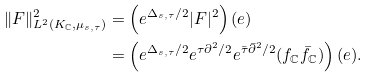Convert formula to latex. <formula><loc_0><loc_0><loc_500><loc_500>\| F \| _ { L ^ { 2 } ( K _ { \mathbb { C } } , \mu _ { s , \tau } ) } ^ { 2 } & = \left ( e ^ { \Delta _ { s , \tau } / 2 } | F | ^ { 2 } \right ) ( e ) \\ & = \left ( e ^ { \Delta _ { s , \tau } / 2 } e ^ { \tau \partial ^ { 2 } / 2 } e ^ { \bar { \tau } \bar { \partial } ^ { 2 } / 2 } ( f _ { \mathbb { C } } \bar { f } _ { \mathbb { C } } ) \right ) ( e ) .</formula> 